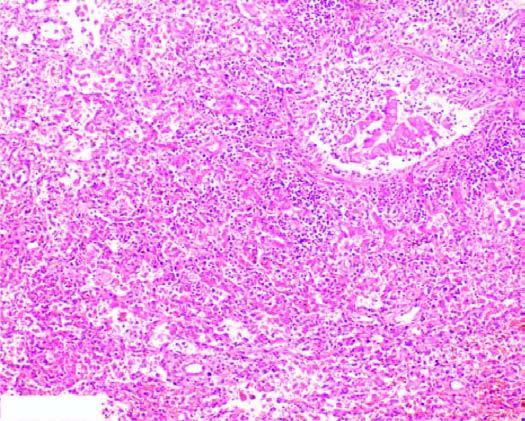re the bronchioles as well as the adjacent alveoli filled with exudate consisting chiefly of neutrophils?
Answer the question using a single word or phrase. Yes 